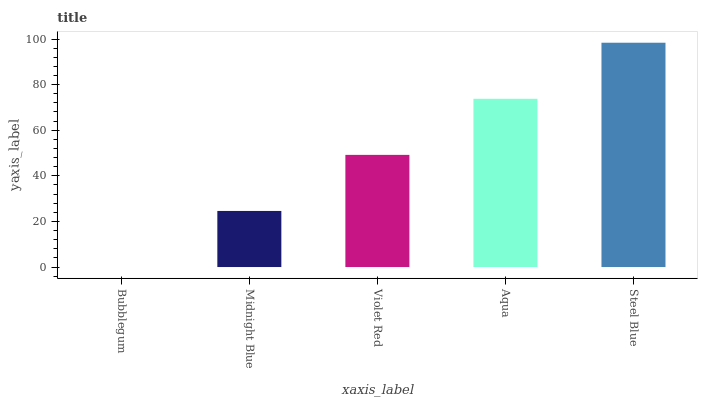Is Bubblegum the minimum?
Answer yes or no. Yes. Is Steel Blue the maximum?
Answer yes or no. Yes. Is Midnight Blue the minimum?
Answer yes or no. No. Is Midnight Blue the maximum?
Answer yes or no. No. Is Midnight Blue greater than Bubblegum?
Answer yes or no. Yes. Is Bubblegum less than Midnight Blue?
Answer yes or no. Yes. Is Bubblegum greater than Midnight Blue?
Answer yes or no. No. Is Midnight Blue less than Bubblegum?
Answer yes or no. No. Is Violet Red the high median?
Answer yes or no. Yes. Is Violet Red the low median?
Answer yes or no. Yes. Is Bubblegum the high median?
Answer yes or no. No. Is Steel Blue the low median?
Answer yes or no. No. 